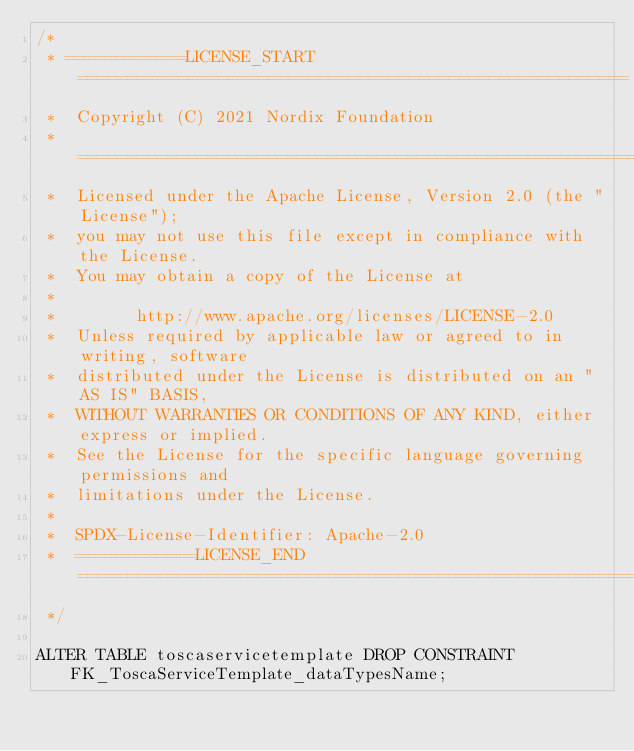Convert code to text. <code><loc_0><loc_0><loc_500><loc_500><_SQL_>/*
 * ============LICENSE_START=======================================================
 *  Copyright (C) 2021 Nordix Foundation
 *  ================================================================================
 *  Licensed under the Apache License, Version 2.0 (the "License");
 *  you may not use this file except in compliance with the License.
 *  You may obtain a copy of the License at
 *
 *        http://www.apache.org/licenses/LICENSE-2.0
 *  Unless required by applicable law or agreed to in writing, software
 *  distributed under the License is distributed on an "AS IS" BASIS,
 *  WITHOUT WARRANTIES OR CONDITIONS OF ANY KIND, either express or implied.
 *  See the License for the specific language governing permissions and
 *  limitations under the License.
 *
 *  SPDX-License-Identifier: Apache-2.0
 *  ============LICENSE_END=========================================================
 */

ALTER TABLE toscaservicetemplate DROP CONSTRAINT FK_ToscaServiceTemplate_dataTypesName;
</code> 